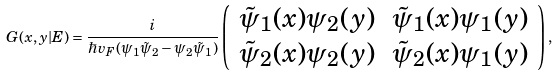<formula> <loc_0><loc_0><loc_500><loc_500>G ( x , y | E ) = \frac { i } { \hbar { v } _ { F } ( \psi _ { 1 } \tilde { \psi } _ { 2 } - \psi _ { 2 } \tilde { \psi } _ { 1 } ) } \left ( \begin{array} { c c } \tilde { \psi } _ { 1 } ( x ) \psi _ { 2 } ( y ) & \tilde { \psi } _ { 1 } ( x ) \psi _ { 1 } ( y ) \\ \tilde { \psi } _ { 2 } ( x ) \psi _ { 2 } ( y ) & \tilde { \psi } _ { 2 } ( x ) \psi _ { 1 } ( y ) \end{array} \right ) ,</formula> 